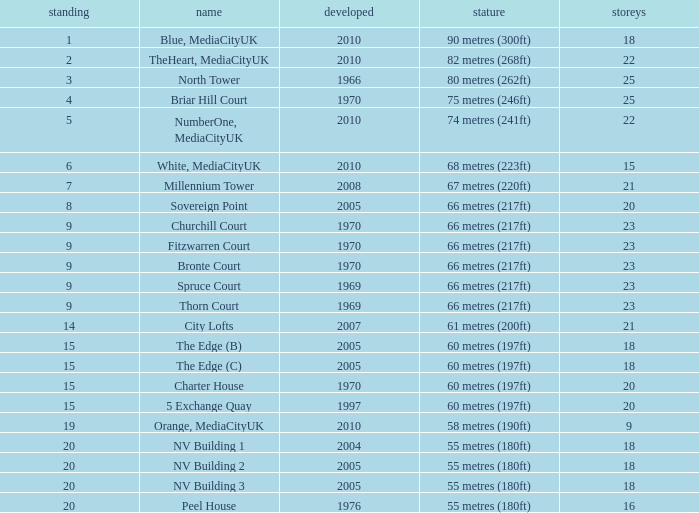What is the total number of Built, when Floors is less than 22, when Rank is less than 8, and when Name is White, Mediacityuk? 1.0. 